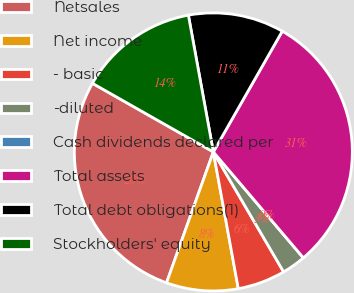Convert chart. <chart><loc_0><loc_0><loc_500><loc_500><pie_chart><fcel>Netsales<fcel>Net income<fcel>- basic<fcel>-diluted<fcel>Cash dividends declared per<fcel>Total assets<fcel>Total debt obligations(1)<fcel>Stockholders' equity<nl><fcel>27.75%<fcel>8.34%<fcel>5.56%<fcel>2.78%<fcel>0.0%<fcel>30.53%<fcel>11.13%<fcel>13.91%<nl></chart> 